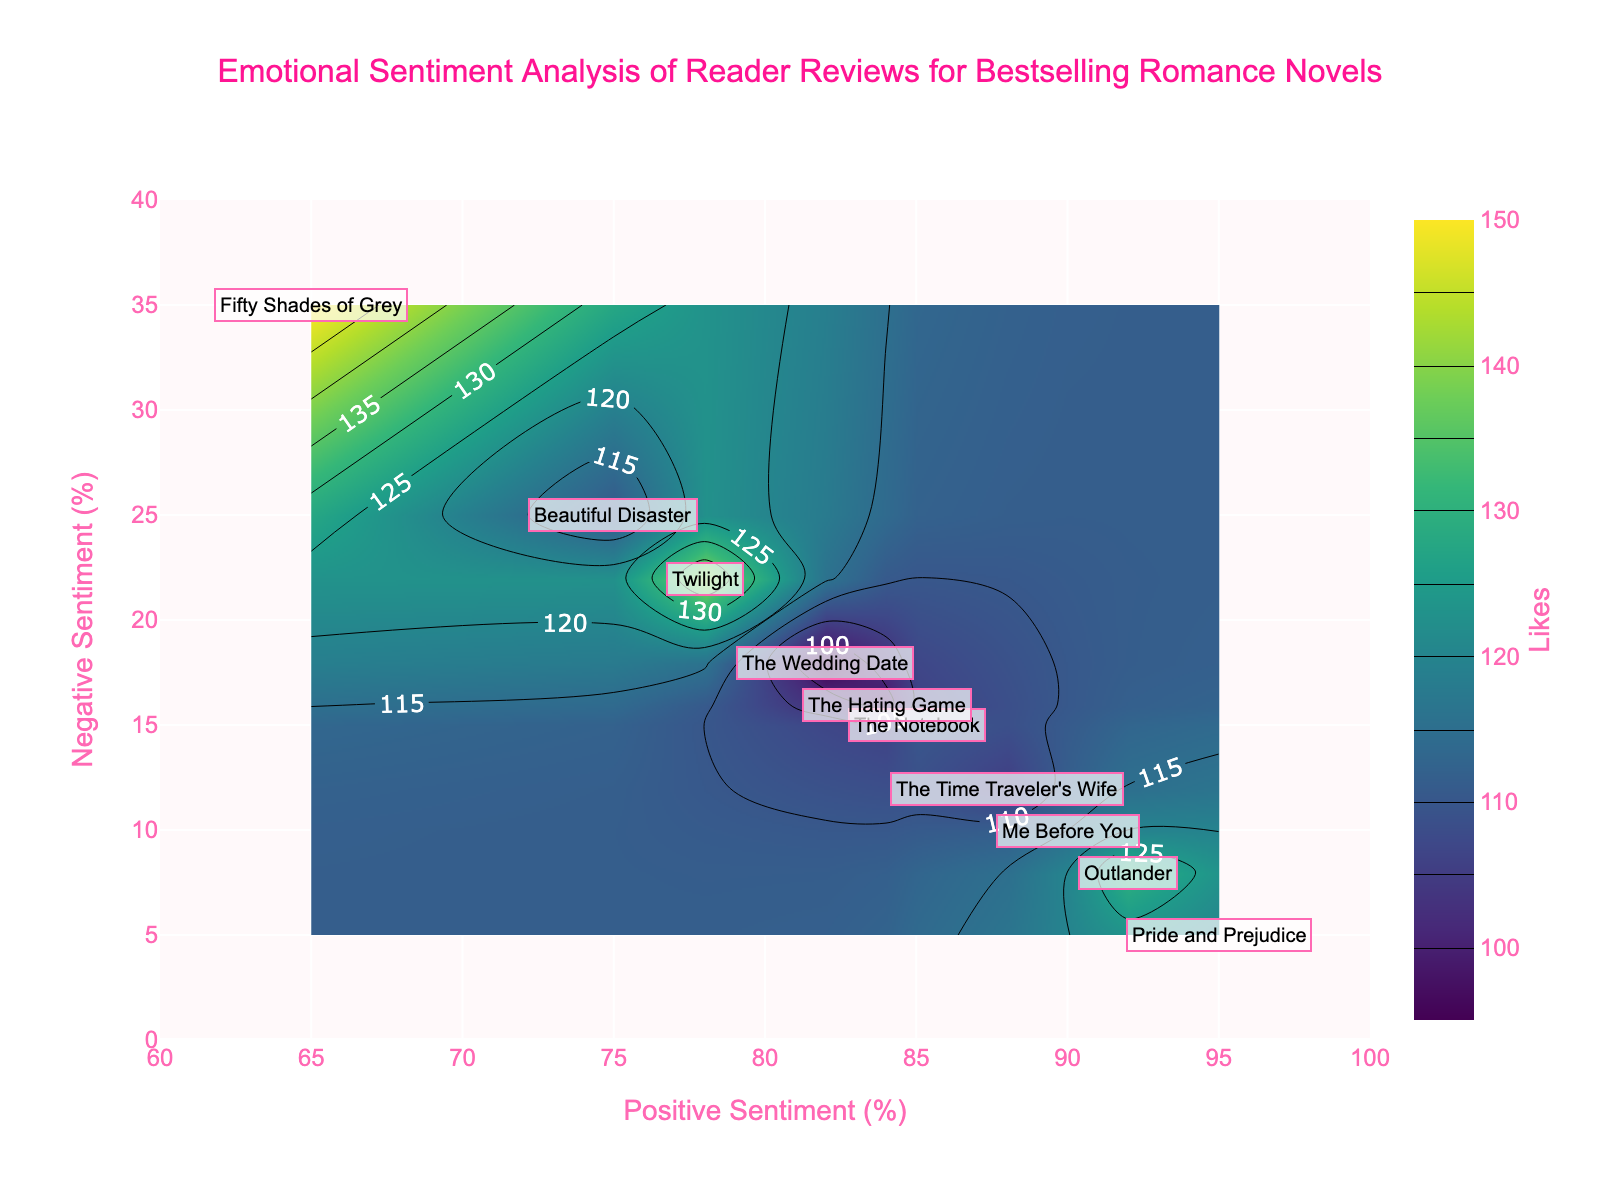What is the title of the plot? The title is typically displayed prominently at the top of the figure. In this plot, it shows the overall subject of the data analysis.
Answer: Emotional Sentiment Analysis of Reader Reviews for Bestselling Romance Novels What does the colorbar represent? The colorbar on the side of the contour plot indicates what the colors within the plot represent. In this case, it shows the number of likes each book received.
Answer: Likes Which book has the highest positive sentiment? By observing the x-axis values (Positive Sentiment), "Pride and Prejudice" has the highest value because its annotation is located furthest to the right.
Answer: Pride and Prejudice How many books received a negative sentiment greater than 20%? By looking at the y-axis (Negative Sentiment) and checking where the book annotations fall, "Twilight", "The Wedding Date", "Beautiful Disaster", "Fifty Shades of Grey" have sentiments greater than 20%.
Answer: 4 Which book is located in the area with the highest number of likes according to the contour plot? By examining the densest, darkest regions indicated by the color scale (representing the most likes) and the annotations within those regions, "Fifty Shades of Grey" is in the most liked region.
Answer: Fifty Shades of Grey What is the sum of likes for "Pride and Prejudice" and "The Time Traveler's Wife"? Look at the annotations showing the number of likes for each of these books and add them together: 120 for "Pride and Prejudice" and 105 for "The Time Traveler's Wife". So, 120 + 105 = 225.
Answer: 225 Which book has the smallest difference between positive and negative sentiment? Calculate the differences between positive and negative sentiments for each book. "Outlander" has 92% positive and 8% negative, giving a difference of 84. Verify against the rest to confirm.
Answer: Outlander Which book title is placed at approximately (85, 15) on the plot? Look at the coordinates on the plot for the annotation near (85, 15). The book title "The Notebook" is located approximately at these coordinates.
Answer: The Notebook How does "Twilight" compare in terms of positive sentiment and dislikes? "Twilight" can be seen with a positive sentiment around 78% (low compared to many others) and dislikes around 40 (higher compared to others). So, it has a lower positive sentiment but more dislikes.
Answer: Lower positive sentiment and more dislikes How do the sentiments of "The Hating Game" compare to "The Wedding Date"? "The Hating Game" has 84% positive and 16% negative sentiment. "The Wedding Date" has 82% positive and 18% negative sentiment. Hence, "The Hating Game" has slightly better sentiments than "The Wedding Date".
Answer: Slightly better sentiments 